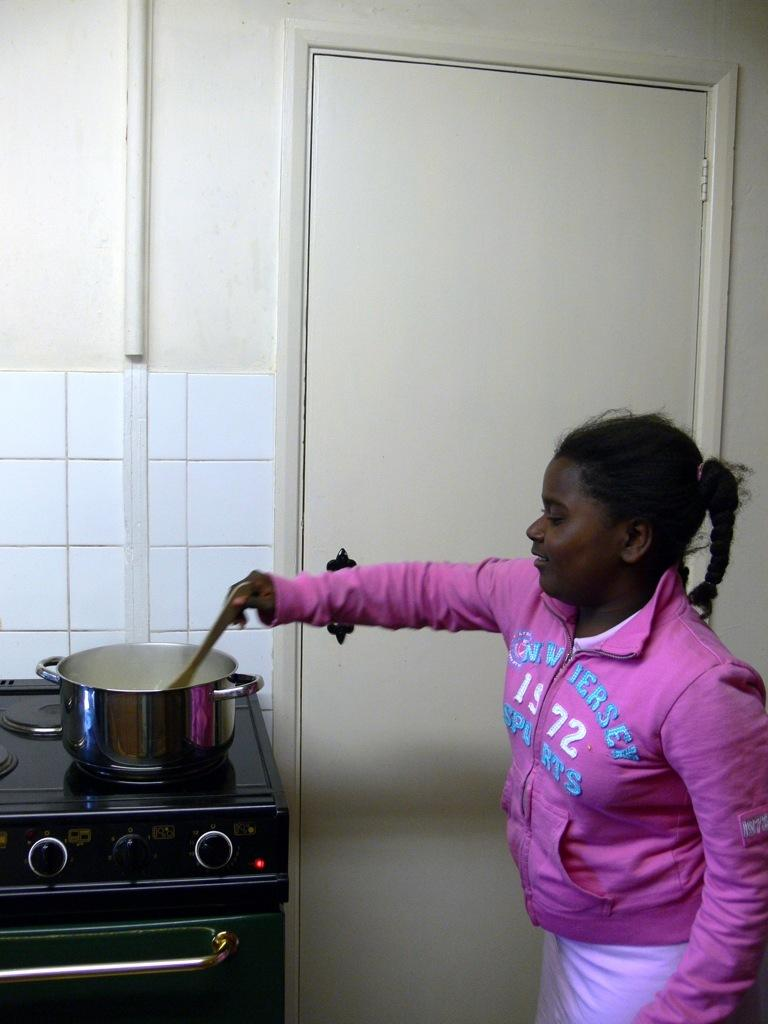<image>
Write a terse but informative summary of the picture. A girl in a pink Converse Sports sweatshirt stirs the pot on a stove. 